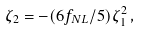Convert formula to latex. <formula><loc_0><loc_0><loc_500><loc_500>\zeta _ { 2 } = - ( 6 f _ { N L } / 5 ) \zeta _ { 1 } ^ { 2 } \, ,</formula> 